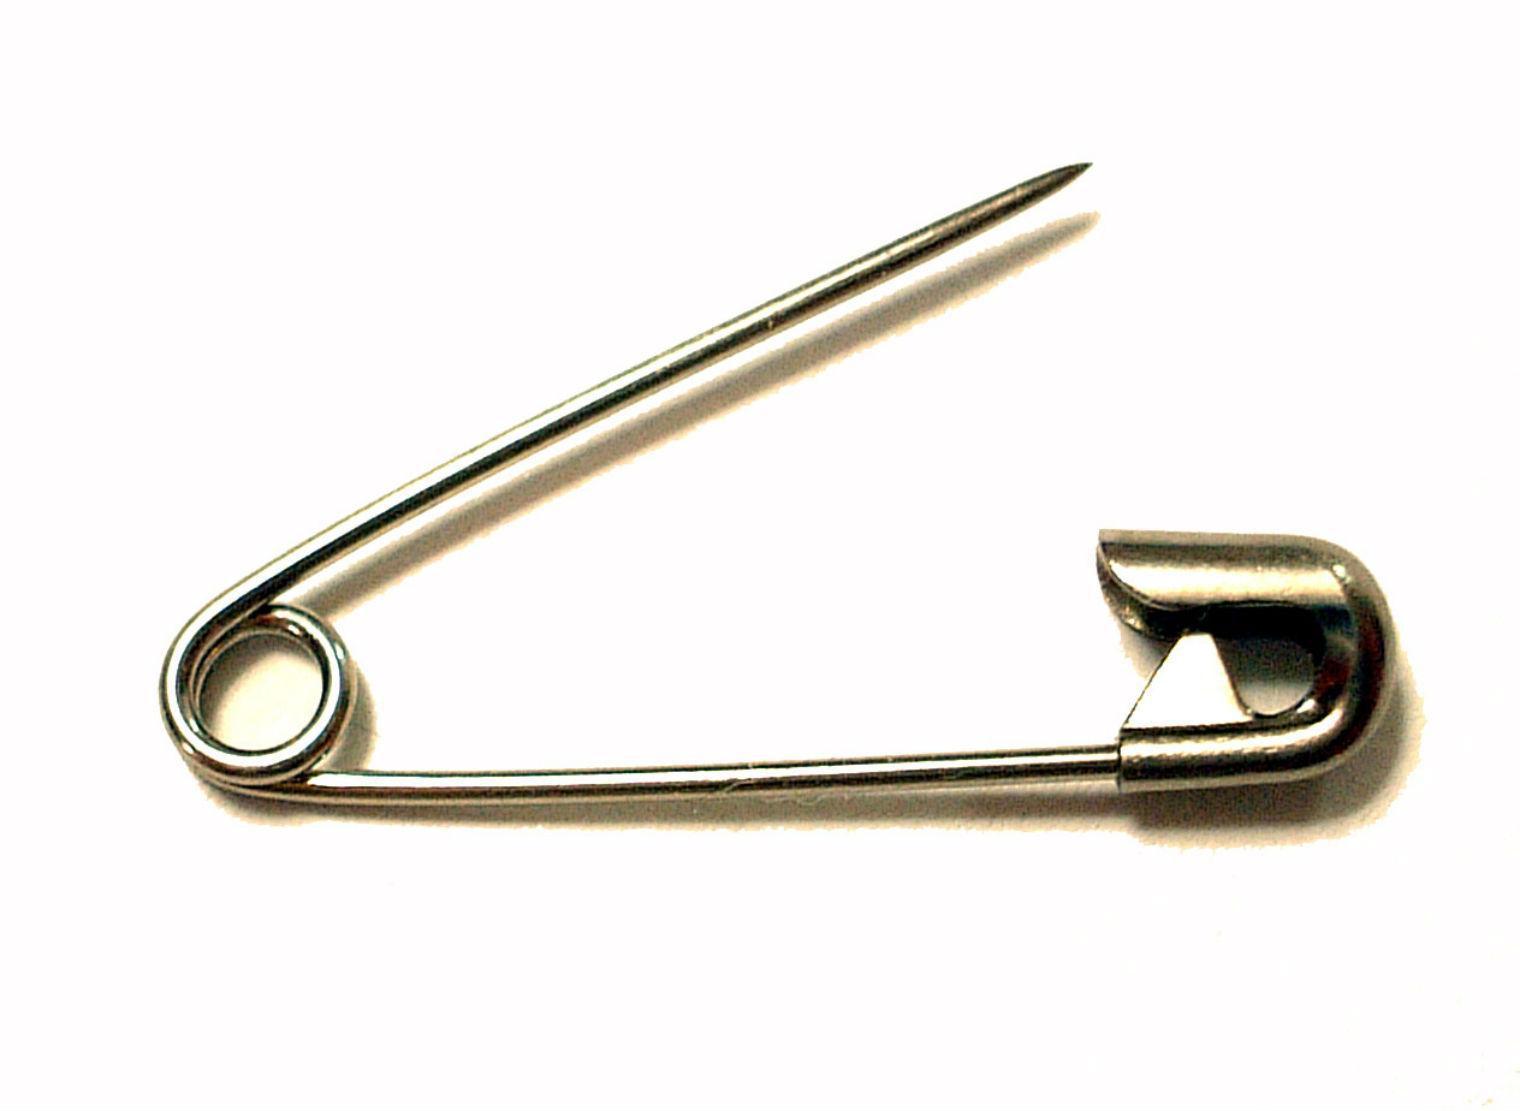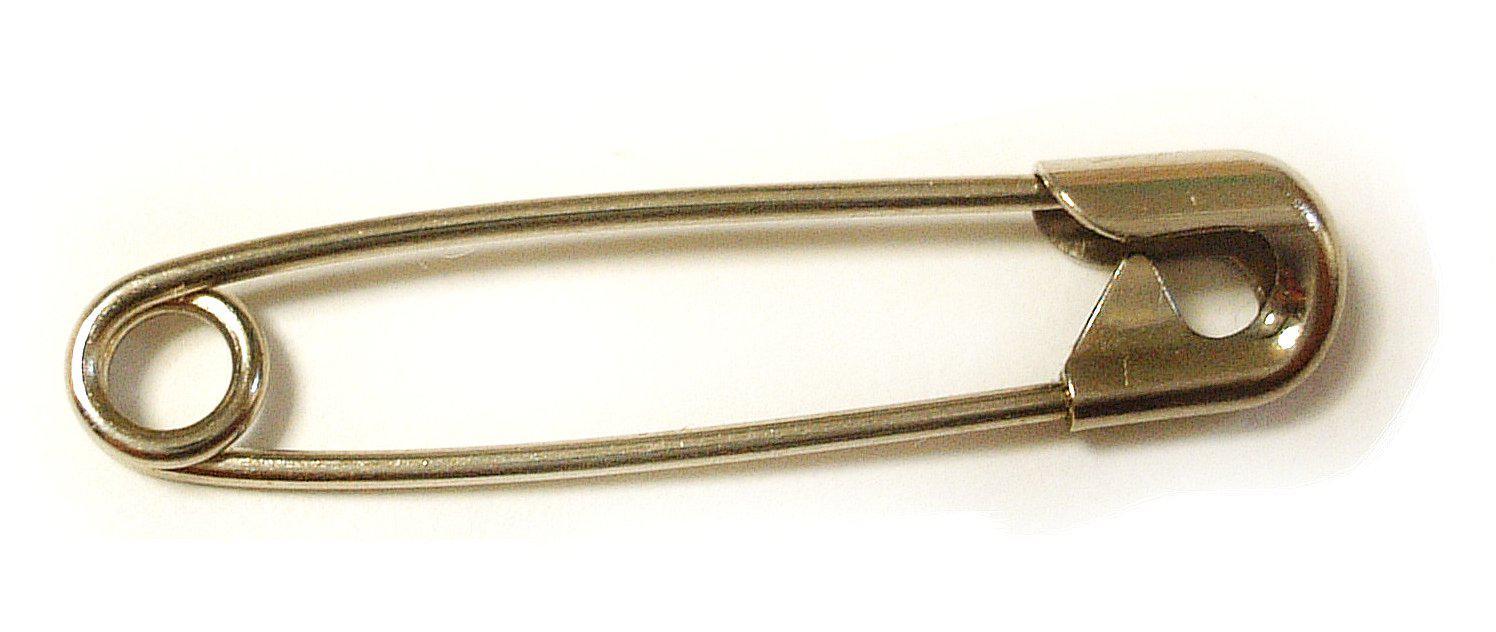The first image is the image on the left, the second image is the image on the right. Evaluate the accuracy of this statement regarding the images: "An image shows one standard type closed safety pin, with a loop on one end and a metal cap clasp on the other.". Is it true? Answer yes or no. Yes. The first image is the image on the left, the second image is the image on the right. Assess this claim about the two images: "One safety pin is in the closed position, while a second safety pin of the same color, with its shadow clearly visible, is open.". Correct or not? Answer yes or no. Yes. 